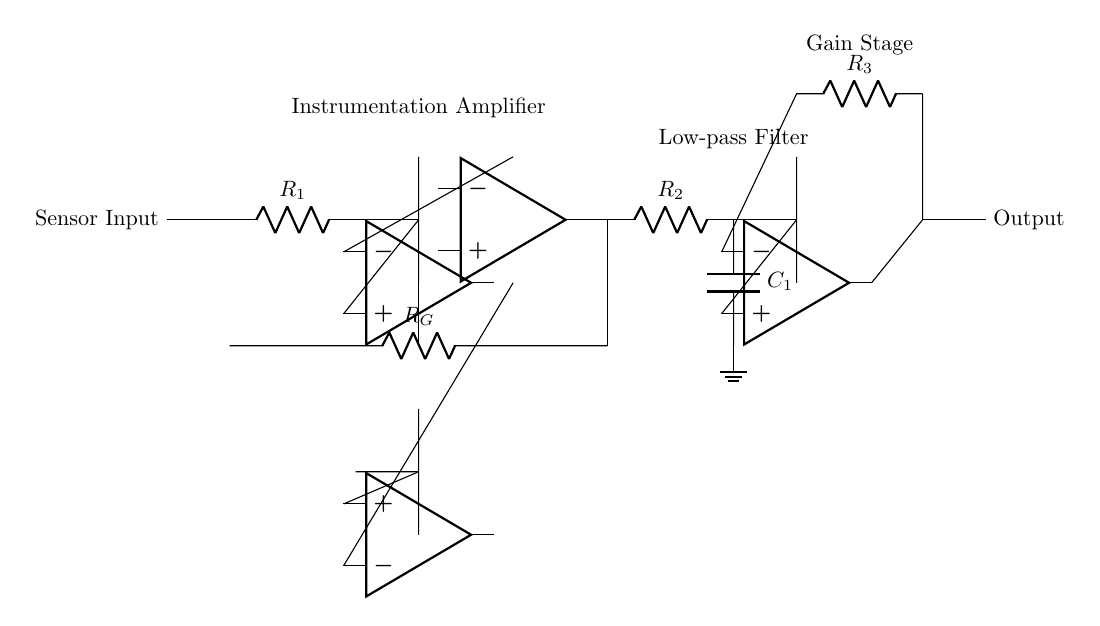What type of amplifier is used in this circuit? The circuit diagram utilizes an instrumentation amplifier, which is indicated by the label and the configuration of the operational amplifiers that amplify the differential input signal.
Answer: instrumentation amplifier What does the resistor R_G represent? R_G represents the gain-setting resistor for the instrumentation amplifier, which determines the amplification factor of the input signal based on its resistance value.
Answer: gain-setting resistor Which components form the low-pass filter in the circuit? The low-pass filter is formed by the resistor R_2 and the capacitor C_1, working together to filter out high-frequency noise from the signal before it reaches the output.
Answer: R_2 and C_1 What is the purpose of the gain stage in this circuit? The gain stage increases the amplitude of the signal after it has been filtered, ensuring that the output signal is at a suitable level for further processing or for driving the next stage in the system.
Answer: increase signal amplitude How do the operational amplifiers in the circuit improve signal accuracy? The operational amplifiers (instrumentation amplifier and gain stage) provide high input impedance and low output impedance, which minimizes loading effects and enhances the overall signal integrity by amplifying and conditioning the sensor signal accurately.
Answer: improve signal integrity What will happen if R_2 is decreased significantly? If R_2 is decreased, the cutoff frequency of the low-pass filter will increase, allowing higher frequency components (like noise) to pass through, which may degrade the quality of the output signal.
Answer: higher cutoff frequency What does the output node represent in this circuit? The output node represents the conditioned analog signal that has been amplified and filtered, ready to be sent to subsequent stages of control systems for further processing or analysis.
Answer: conditioned analog signal 